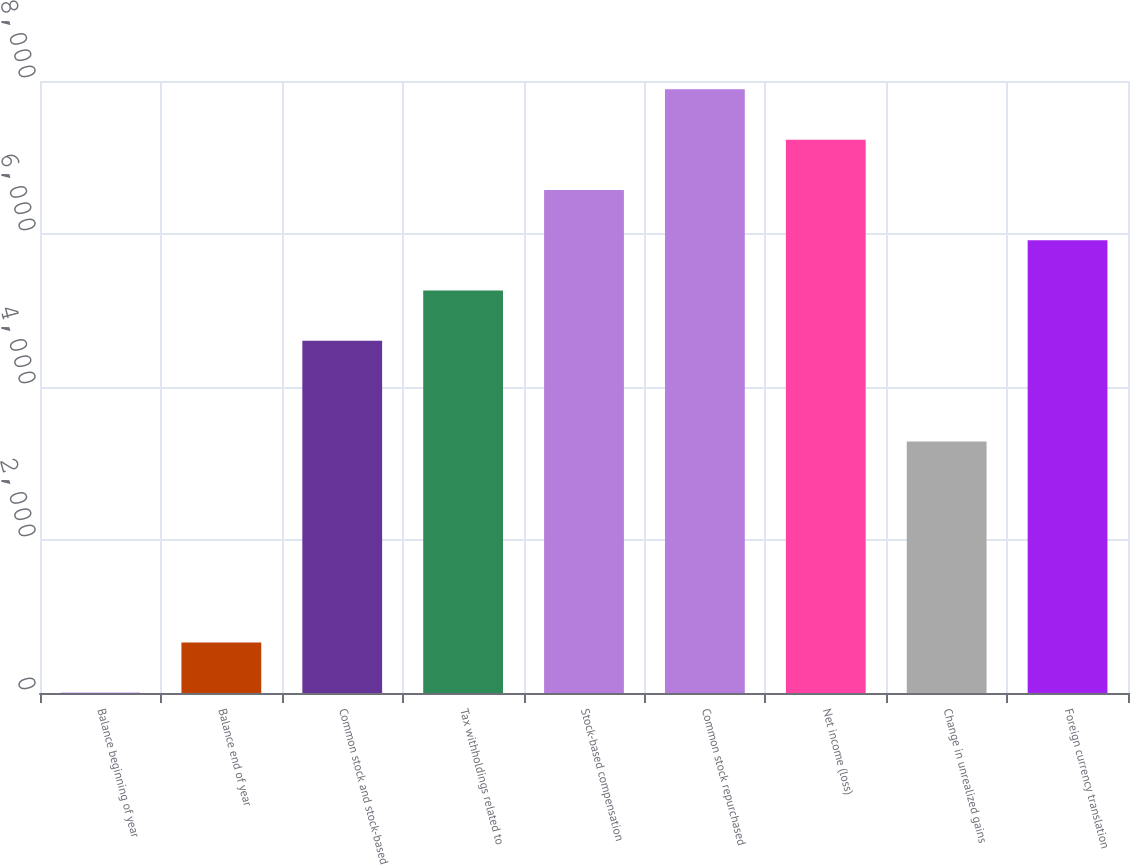Convert chart to OTSL. <chart><loc_0><loc_0><loc_500><loc_500><bar_chart><fcel>Balance beginning of year<fcel>Balance end of year<fcel>Common stock and stock-based<fcel>Tax withholdings related to<fcel>Stock-based compensation<fcel>Common stock repurchased<fcel>Net income (loss)<fcel>Change in unrealized gains<fcel>Foreign currency translation<nl><fcel>2<fcel>659.4<fcel>4603.8<fcel>5261.2<fcel>6576<fcel>7890.8<fcel>7233.4<fcel>3289<fcel>5918.6<nl></chart> 